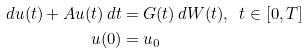<formula> <loc_0><loc_0><loc_500><loc_500>d u ( t ) + A u ( t ) \, d t & = G ( t ) \, d W ( t ) , \ \ t \in [ 0 , T ] \\ u ( 0 ) & = u _ { 0 }</formula> 